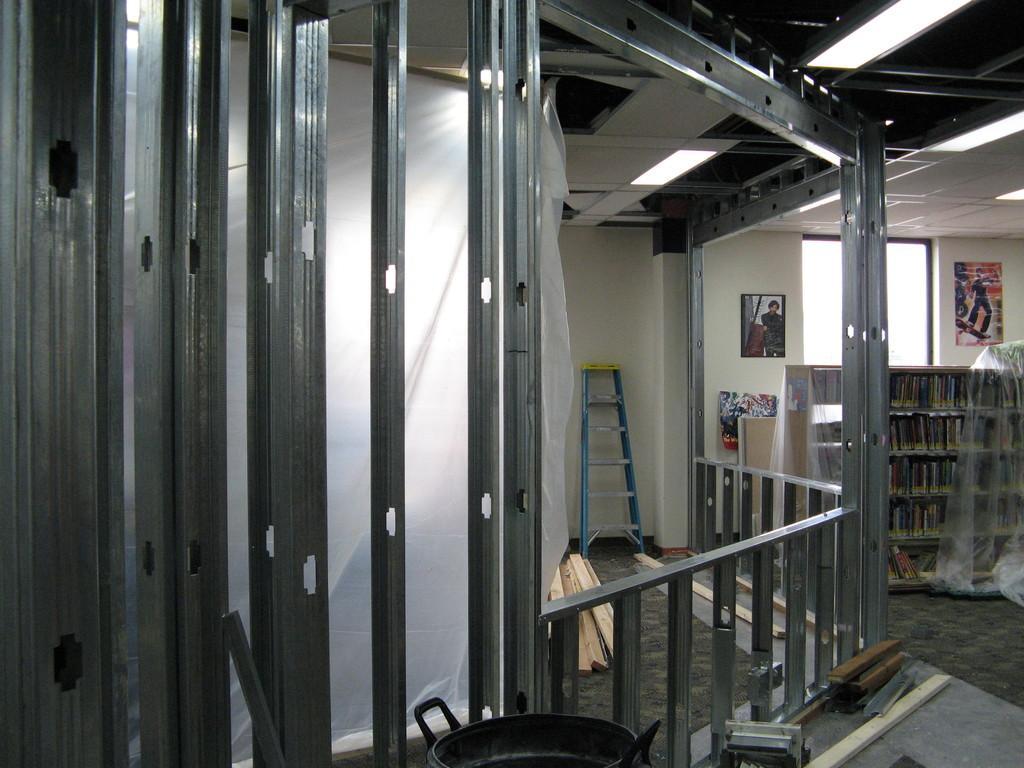Could you give a brief overview of what you see in this image? This image consists of a house in which we can see the metal rods. At the there is a pan. On the right, there is a bookshelf in which there are many books. In the background, there is a wall on which there is a frame and wall poster. And there is a window. And we can see ladder near the wall. 